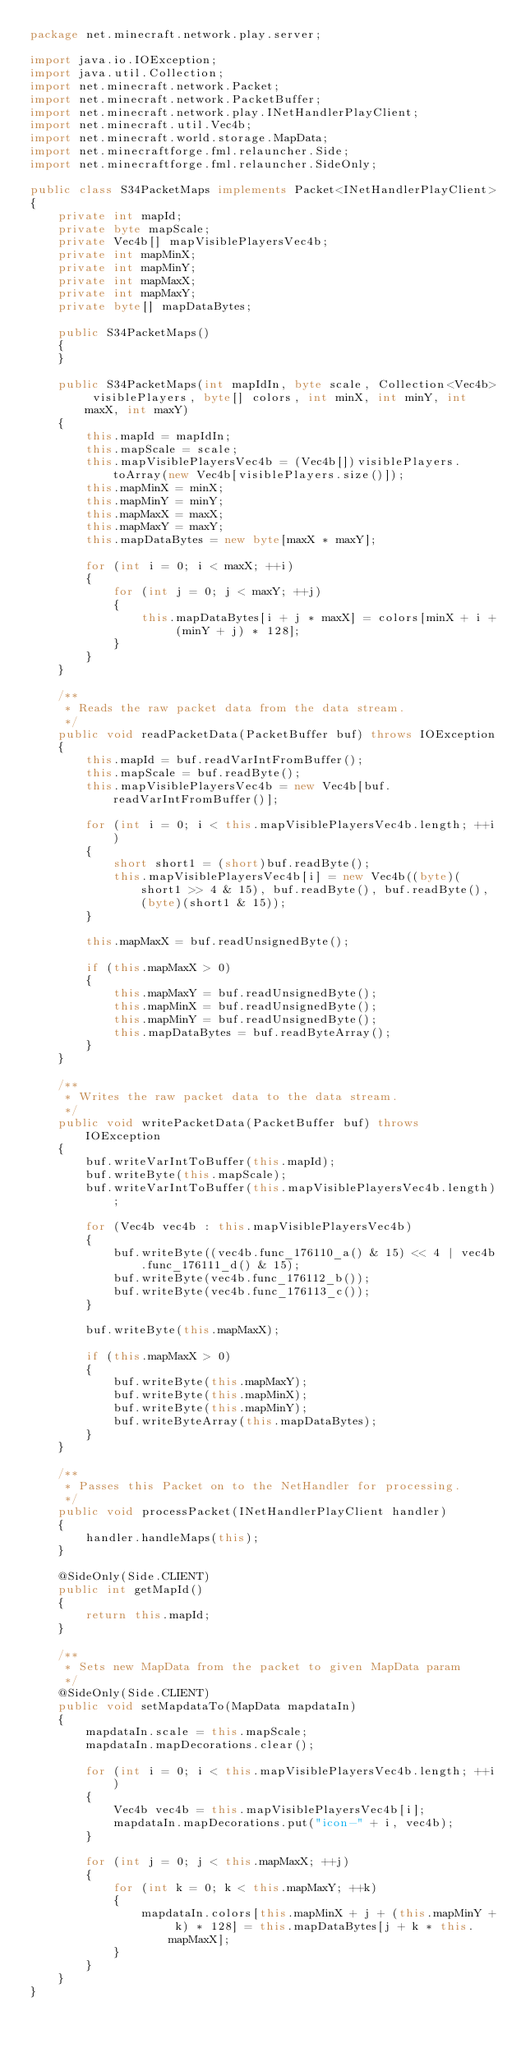<code> <loc_0><loc_0><loc_500><loc_500><_Java_>package net.minecraft.network.play.server;

import java.io.IOException;
import java.util.Collection;
import net.minecraft.network.Packet;
import net.minecraft.network.PacketBuffer;
import net.minecraft.network.play.INetHandlerPlayClient;
import net.minecraft.util.Vec4b;
import net.minecraft.world.storage.MapData;
import net.minecraftforge.fml.relauncher.Side;
import net.minecraftforge.fml.relauncher.SideOnly;

public class S34PacketMaps implements Packet<INetHandlerPlayClient>
{
    private int mapId;
    private byte mapScale;
    private Vec4b[] mapVisiblePlayersVec4b;
    private int mapMinX;
    private int mapMinY;
    private int mapMaxX;
    private int mapMaxY;
    private byte[] mapDataBytes;

    public S34PacketMaps()
    {
    }

    public S34PacketMaps(int mapIdIn, byte scale, Collection<Vec4b> visiblePlayers, byte[] colors, int minX, int minY, int maxX, int maxY)
    {
        this.mapId = mapIdIn;
        this.mapScale = scale;
        this.mapVisiblePlayersVec4b = (Vec4b[])visiblePlayers.toArray(new Vec4b[visiblePlayers.size()]);
        this.mapMinX = minX;
        this.mapMinY = minY;
        this.mapMaxX = maxX;
        this.mapMaxY = maxY;
        this.mapDataBytes = new byte[maxX * maxY];

        for (int i = 0; i < maxX; ++i)
        {
            for (int j = 0; j < maxY; ++j)
            {
                this.mapDataBytes[i + j * maxX] = colors[minX + i + (minY + j) * 128];
            }
        }
    }

    /**
     * Reads the raw packet data from the data stream.
     */
    public void readPacketData(PacketBuffer buf) throws IOException
    {
        this.mapId = buf.readVarIntFromBuffer();
        this.mapScale = buf.readByte();
        this.mapVisiblePlayersVec4b = new Vec4b[buf.readVarIntFromBuffer()];

        for (int i = 0; i < this.mapVisiblePlayersVec4b.length; ++i)
        {
            short short1 = (short)buf.readByte();
            this.mapVisiblePlayersVec4b[i] = new Vec4b((byte)(short1 >> 4 & 15), buf.readByte(), buf.readByte(), (byte)(short1 & 15));
        }

        this.mapMaxX = buf.readUnsignedByte();

        if (this.mapMaxX > 0)
        {
            this.mapMaxY = buf.readUnsignedByte();
            this.mapMinX = buf.readUnsignedByte();
            this.mapMinY = buf.readUnsignedByte();
            this.mapDataBytes = buf.readByteArray();
        }
    }

    /**
     * Writes the raw packet data to the data stream.
     */
    public void writePacketData(PacketBuffer buf) throws IOException
    {
        buf.writeVarIntToBuffer(this.mapId);
        buf.writeByte(this.mapScale);
        buf.writeVarIntToBuffer(this.mapVisiblePlayersVec4b.length);

        for (Vec4b vec4b : this.mapVisiblePlayersVec4b)
        {
            buf.writeByte((vec4b.func_176110_a() & 15) << 4 | vec4b.func_176111_d() & 15);
            buf.writeByte(vec4b.func_176112_b());
            buf.writeByte(vec4b.func_176113_c());
        }

        buf.writeByte(this.mapMaxX);

        if (this.mapMaxX > 0)
        {
            buf.writeByte(this.mapMaxY);
            buf.writeByte(this.mapMinX);
            buf.writeByte(this.mapMinY);
            buf.writeByteArray(this.mapDataBytes);
        }
    }

    /**
     * Passes this Packet on to the NetHandler for processing.
     */
    public void processPacket(INetHandlerPlayClient handler)
    {
        handler.handleMaps(this);
    }

    @SideOnly(Side.CLIENT)
    public int getMapId()
    {
        return this.mapId;
    }

    /**
     * Sets new MapData from the packet to given MapData param
     */
    @SideOnly(Side.CLIENT)
    public void setMapdataTo(MapData mapdataIn)
    {
        mapdataIn.scale = this.mapScale;
        mapdataIn.mapDecorations.clear();

        for (int i = 0; i < this.mapVisiblePlayersVec4b.length; ++i)
        {
            Vec4b vec4b = this.mapVisiblePlayersVec4b[i];
            mapdataIn.mapDecorations.put("icon-" + i, vec4b);
        }

        for (int j = 0; j < this.mapMaxX; ++j)
        {
            for (int k = 0; k < this.mapMaxY; ++k)
            {
                mapdataIn.colors[this.mapMinX + j + (this.mapMinY + k) * 128] = this.mapDataBytes[j + k * this.mapMaxX];
            }
        }
    }
}</code> 